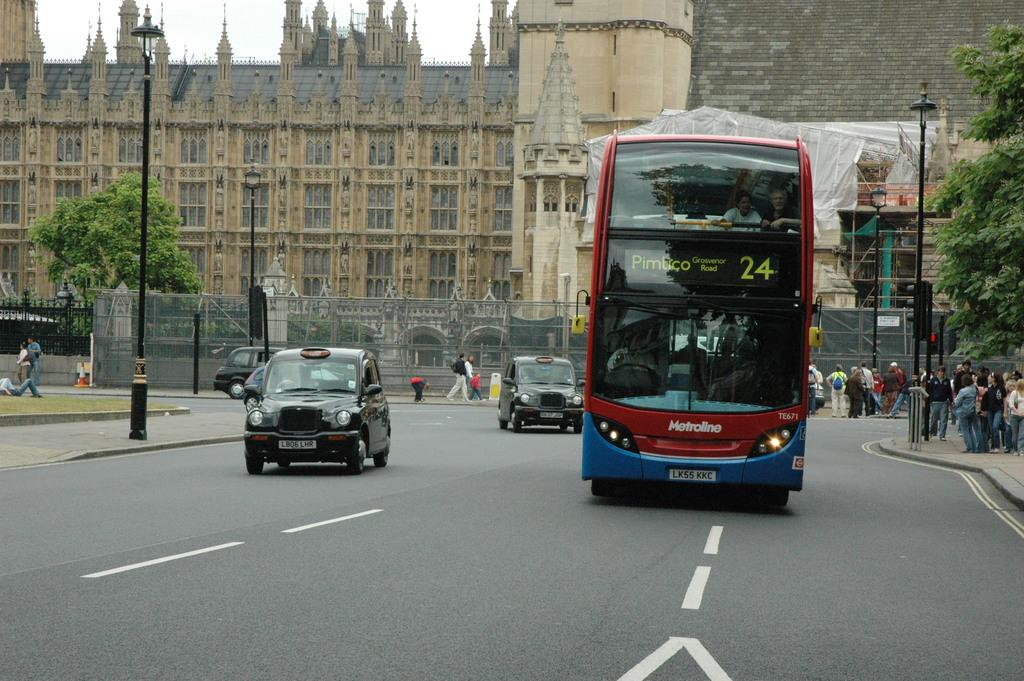What is the main subject of the image? The main subject of the image is a bus. What is the bus doing in the image? The bus is moving on the road. What type of vehicles are beside the bus? There are black cars beside the bus. What can be seen behind the bus? There is a brown building behind the bus. What is visible at the top of the image? The sky is visible at the top of the image. What type of guitar can be heard playing in the image? There is no guitar or sound present in the image; it is a still image of a bus moving on the road. How many people are coughing in the image? There is no indication of anyone coughing in the image. 